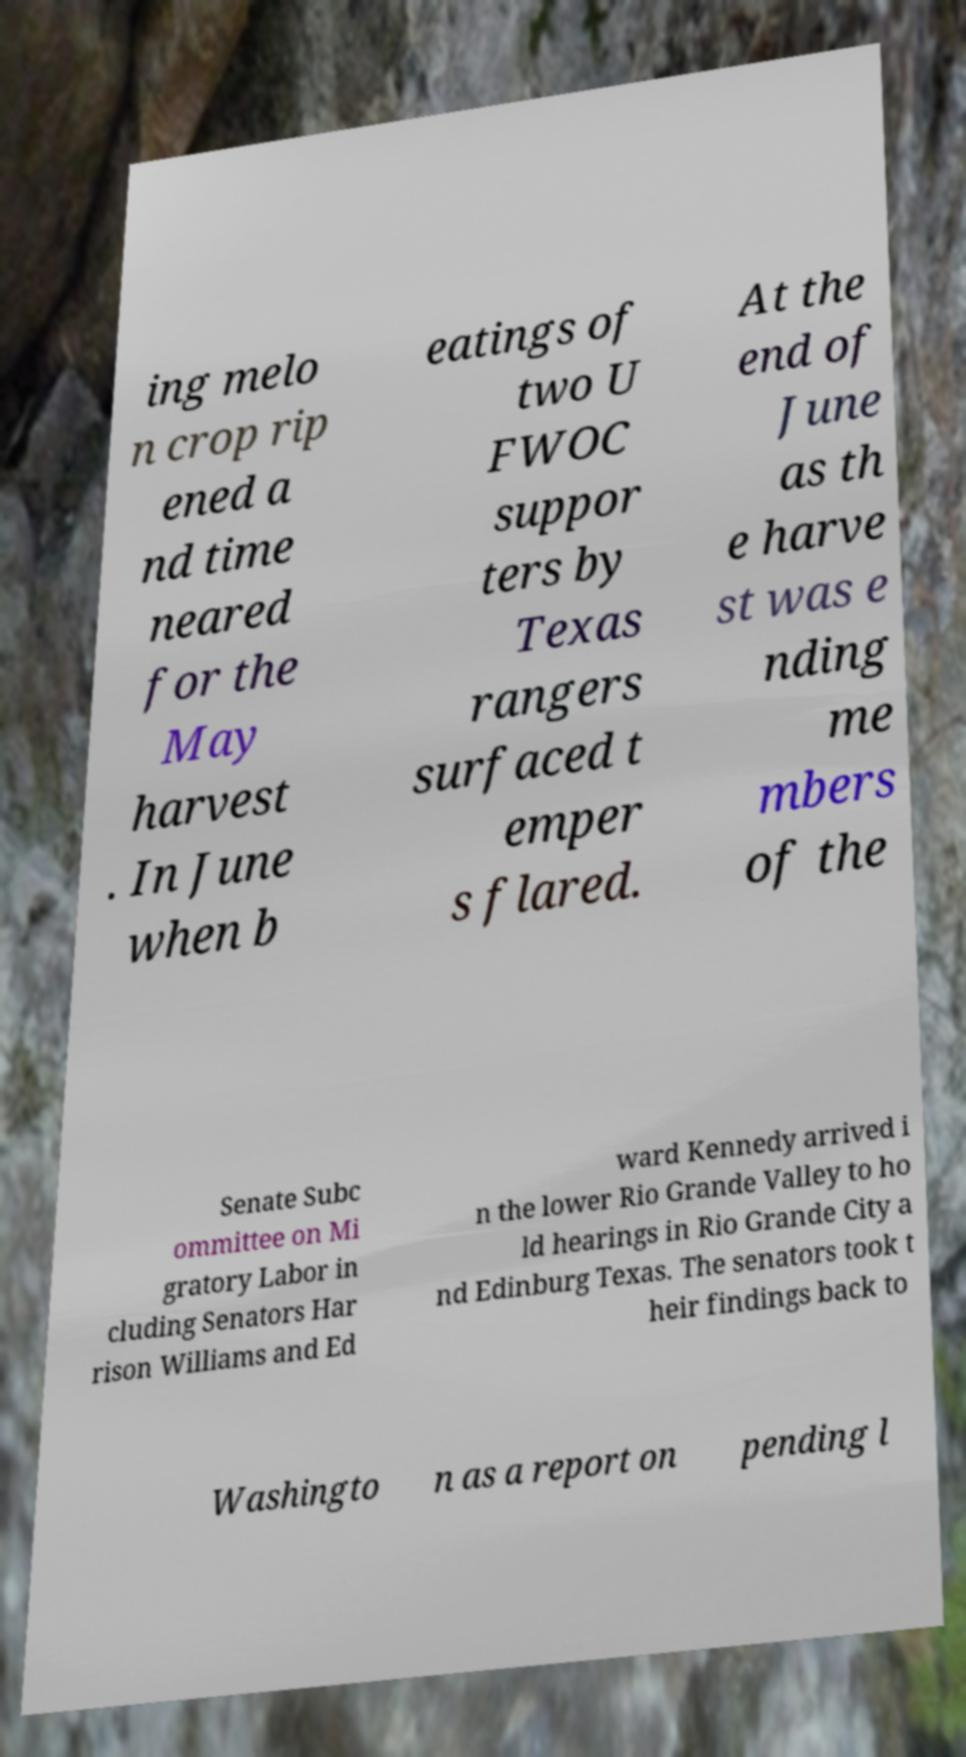Please read and relay the text visible in this image. What does it say? ing melo n crop rip ened a nd time neared for the May harvest . In June when b eatings of two U FWOC suppor ters by Texas rangers surfaced t emper s flared. At the end of June as th e harve st was e nding me mbers of the Senate Subc ommittee on Mi gratory Labor in cluding Senators Har rison Williams and Ed ward Kennedy arrived i n the lower Rio Grande Valley to ho ld hearings in Rio Grande City a nd Edinburg Texas. The senators took t heir findings back to Washingto n as a report on pending l 